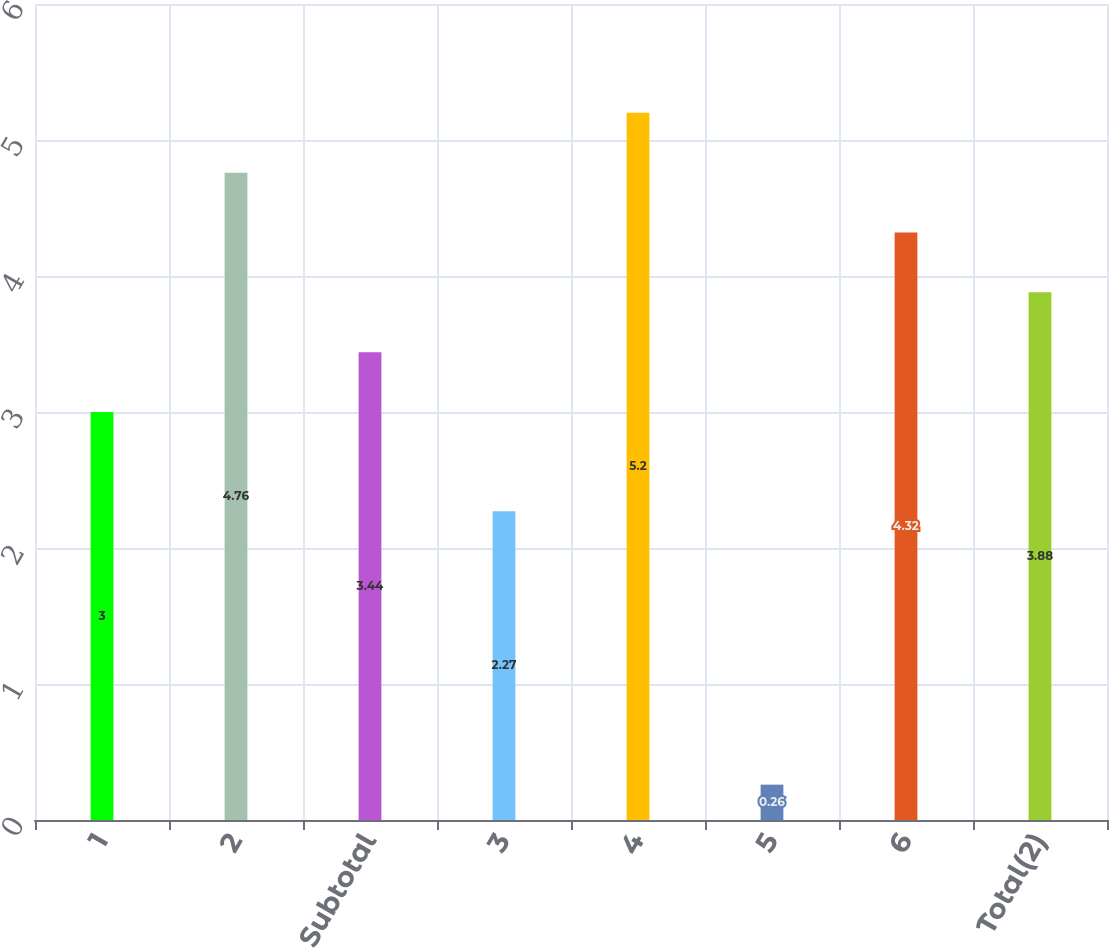<chart> <loc_0><loc_0><loc_500><loc_500><bar_chart><fcel>1<fcel>2<fcel>Subtotal<fcel>3<fcel>4<fcel>5<fcel>6<fcel>Total(2)<nl><fcel>3<fcel>4.76<fcel>3.44<fcel>2.27<fcel>5.2<fcel>0.26<fcel>4.32<fcel>3.88<nl></chart> 